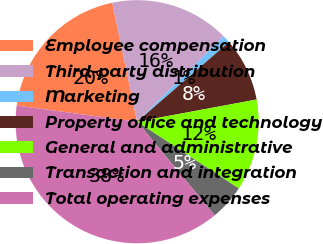<chart> <loc_0><loc_0><loc_500><loc_500><pie_chart><fcel>Employee compensation<fcel>Third-party distribution<fcel>Marketing<fcel>Property office and technology<fcel>General and administrative<fcel>Transaction and integration<fcel>Total operating expenses<nl><fcel>19.59%<fcel>15.88%<fcel>1.03%<fcel>8.45%<fcel>12.17%<fcel>4.74%<fcel>38.14%<nl></chart> 